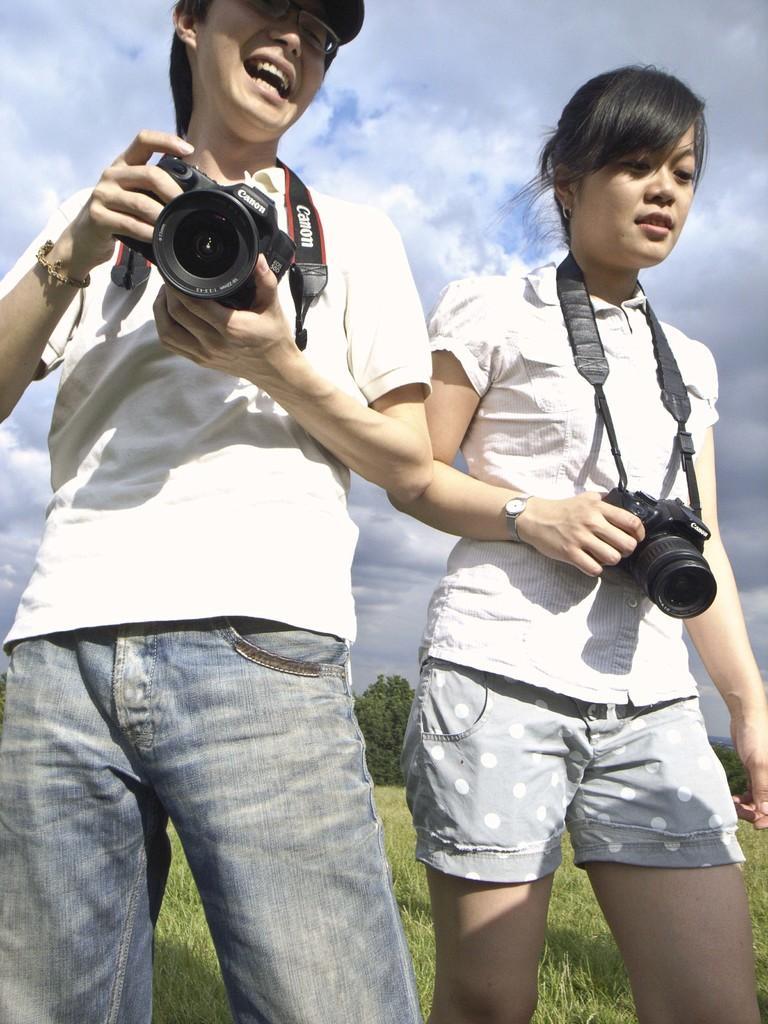In one or two sentences, can you explain what this image depicts? In this image I can see there is a man and a woman holding a camera in their hands. 